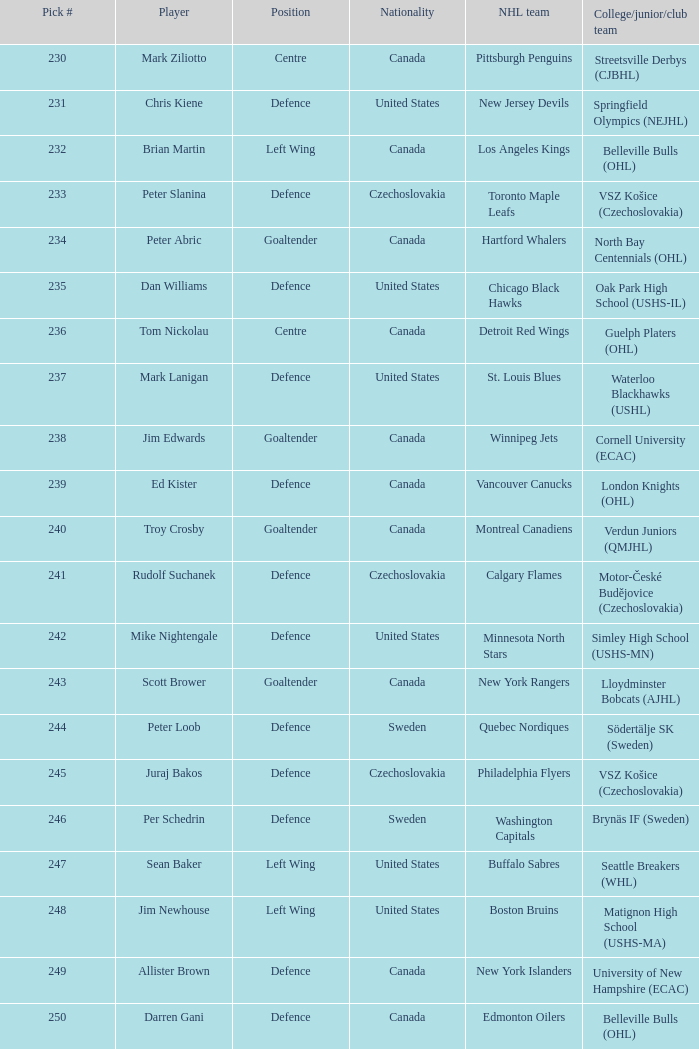List the players for team brynäs if (sweden). Per Schedrin. 